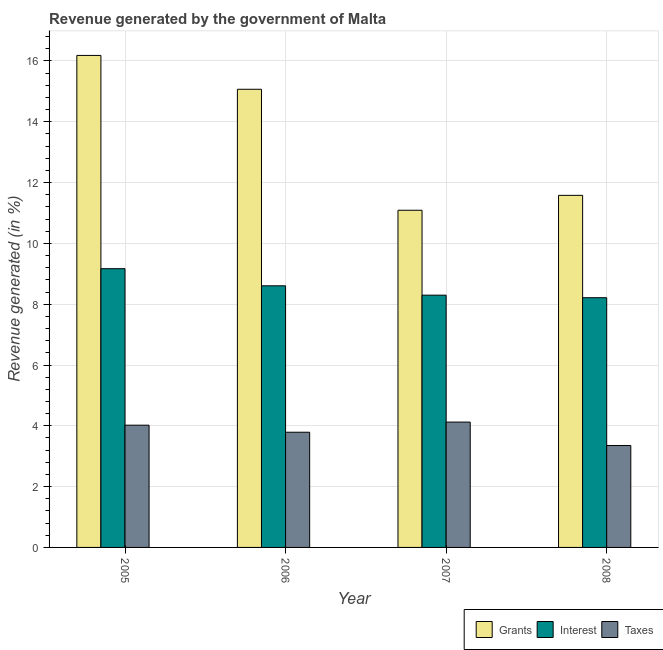Are the number of bars per tick equal to the number of legend labels?
Give a very brief answer. Yes. What is the label of the 2nd group of bars from the left?
Your response must be concise. 2006. In how many cases, is the number of bars for a given year not equal to the number of legend labels?
Offer a very short reply. 0. What is the percentage of revenue generated by grants in 2008?
Provide a succinct answer. 11.58. Across all years, what is the maximum percentage of revenue generated by taxes?
Offer a terse response. 4.12. Across all years, what is the minimum percentage of revenue generated by taxes?
Your response must be concise. 3.35. In which year was the percentage of revenue generated by grants maximum?
Offer a very short reply. 2005. What is the total percentage of revenue generated by taxes in the graph?
Make the answer very short. 15.29. What is the difference between the percentage of revenue generated by interest in 2007 and that in 2008?
Provide a short and direct response. 0.08. What is the difference between the percentage of revenue generated by grants in 2008 and the percentage of revenue generated by interest in 2005?
Your answer should be compact. -4.6. What is the average percentage of revenue generated by interest per year?
Keep it short and to the point. 8.57. In the year 2007, what is the difference between the percentage of revenue generated by interest and percentage of revenue generated by taxes?
Give a very brief answer. 0. What is the ratio of the percentage of revenue generated by taxes in 2006 to that in 2008?
Your response must be concise. 1.13. Is the difference between the percentage of revenue generated by taxes in 2006 and 2008 greater than the difference between the percentage of revenue generated by interest in 2006 and 2008?
Your answer should be very brief. No. What is the difference between the highest and the second highest percentage of revenue generated by grants?
Provide a short and direct response. 1.11. What is the difference between the highest and the lowest percentage of revenue generated by taxes?
Ensure brevity in your answer.  0.77. In how many years, is the percentage of revenue generated by interest greater than the average percentage of revenue generated by interest taken over all years?
Your answer should be very brief. 2. Is the sum of the percentage of revenue generated by taxes in 2005 and 2007 greater than the maximum percentage of revenue generated by grants across all years?
Provide a short and direct response. Yes. What does the 3rd bar from the left in 2008 represents?
Provide a short and direct response. Taxes. What does the 1st bar from the right in 2007 represents?
Give a very brief answer. Taxes. Is it the case that in every year, the sum of the percentage of revenue generated by grants and percentage of revenue generated by interest is greater than the percentage of revenue generated by taxes?
Keep it short and to the point. Yes. How many bars are there?
Ensure brevity in your answer.  12. What is the difference between two consecutive major ticks on the Y-axis?
Your response must be concise. 2. Are the values on the major ticks of Y-axis written in scientific E-notation?
Give a very brief answer. No. Does the graph contain any zero values?
Ensure brevity in your answer.  No. How many legend labels are there?
Your answer should be very brief. 3. What is the title of the graph?
Ensure brevity in your answer.  Revenue generated by the government of Malta. What is the label or title of the Y-axis?
Provide a short and direct response. Revenue generated (in %). What is the Revenue generated (in %) in Grants in 2005?
Offer a very short reply. 16.18. What is the Revenue generated (in %) of Interest in 2005?
Your answer should be very brief. 9.17. What is the Revenue generated (in %) of Taxes in 2005?
Your answer should be very brief. 4.02. What is the Revenue generated (in %) in Grants in 2006?
Provide a succinct answer. 15.07. What is the Revenue generated (in %) in Interest in 2006?
Offer a very short reply. 8.6. What is the Revenue generated (in %) in Taxes in 2006?
Make the answer very short. 3.79. What is the Revenue generated (in %) in Grants in 2007?
Provide a succinct answer. 11.09. What is the Revenue generated (in %) in Interest in 2007?
Offer a terse response. 8.3. What is the Revenue generated (in %) in Taxes in 2007?
Provide a succinct answer. 4.12. What is the Revenue generated (in %) of Grants in 2008?
Make the answer very short. 11.58. What is the Revenue generated (in %) of Interest in 2008?
Keep it short and to the point. 8.21. What is the Revenue generated (in %) in Taxes in 2008?
Offer a very short reply. 3.35. Across all years, what is the maximum Revenue generated (in %) of Grants?
Make the answer very short. 16.18. Across all years, what is the maximum Revenue generated (in %) in Interest?
Ensure brevity in your answer.  9.17. Across all years, what is the maximum Revenue generated (in %) in Taxes?
Provide a succinct answer. 4.12. Across all years, what is the minimum Revenue generated (in %) of Grants?
Provide a short and direct response. 11.09. Across all years, what is the minimum Revenue generated (in %) in Interest?
Offer a very short reply. 8.21. Across all years, what is the minimum Revenue generated (in %) of Taxes?
Make the answer very short. 3.35. What is the total Revenue generated (in %) of Grants in the graph?
Offer a very short reply. 53.92. What is the total Revenue generated (in %) of Interest in the graph?
Provide a short and direct response. 34.28. What is the total Revenue generated (in %) of Taxes in the graph?
Your answer should be compact. 15.29. What is the difference between the Revenue generated (in %) in Grants in 2005 and that in 2006?
Provide a short and direct response. 1.11. What is the difference between the Revenue generated (in %) in Interest in 2005 and that in 2006?
Your answer should be very brief. 0.56. What is the difference between the Revenue generated (in %) in Taxes in 2005 and that in 2006?
Make the answer very short. 0.23. What is the difference between the Revenue generated (in %) in Grants in 2005 and that in 2007?
Offer a terse response. 5.09. What is the difference between the Revenue generated (in %) of Interest in 2005 and that in 2007?
Offer a very short reply. 0.87. What is the difference between the Revenue generated (in %) in Taxes in 2005 and that in 2007?
Offer a terse response. -0.1. What is the difference between the Revenue generated (in %) of Grants in 2005 and that in 2008?
Your response must be concise. 4.6. What is the difference between the Revenue generated (in %) in Interest in 2005 and that in 2008?
Ensure brevity in your answer.  0.95. What is the difference between the Revenue generated (in %) of Taxes in 2005 and that in 2008?
Your response must be concise. 0.67. What is the difference between the Revenue generated (in %) in Grants in 2006 and that in 2007?
Offer a very short reply. 3.98. What is the difference between the Revenue generated (in %) in Interest in 2006 and that in 2007?
Provide a succinct answer. 0.31. What is the difference between the Revenue generated (in %) in Taxes in 2006 and that in 2007?
Your response must be concise. -0.33. What is the difference between the Revenue generated (in %) in Grants in 2006 and that in 2008?
Offer a very short reply. 3.49. What is the difference between the Revenue generated (in %) in Interest in 2006 and that in 2008?
Ensure brevity in your answer.  0.39. What is the difference between the Revenue generated (in %) in Taxes in 2006 and that in 2008?
Make the answer very short. 0.44. What is the difference between the Revenue generated (in %) of Grants in 2007 and that in 2008?
Offer a terse response. -0.49. What is the difference between the Revenue generated (in %) of Interest in 2007 and that in 2008?
Provide a succinct answer. 0.08. What is the difference between the Revenue generated (in %) of Taxes in 2007 and that in 2008?
Make the answer very short. 0.77. What is the difference between the Revenue generated (in %) in Grants in 2005 and the Revenue generated (in %) in Interest in 2006?
Give a very brief answer. 7.58. What is the difference between the Revenue generated (in %) in Grants in 2005 and the Revenue generated (in %) in Taxes in 2006?
Keep it short and to the point. 12.39. What is the difference between the Revenue generated (in %) in Interest in 2005 and the Revenue generated (in %) in Taxes in 2006?
Keep it short and to the point. 5.38. What is the difference between the Revenue generated (in %) in Grants in 2005 and the Revenue generated (in %) in Interest in 2007?
Provide a succinct answer. 7.89. What is the difference between the Revenue generated (in %) of Grants in 2005 and the Revenue generated (in %) of Taxes in 2007?
Offer a very short reply. 12.06. What is the difference between the Revenue generated (in %) of Interest in 2005 and the Revenue generated (in %) of Taxes in 2007?
Your answer should be compact. 5.05. What is the difference between the Revenue generated (in %) in Grants in 2005 and the Revenue generated (in %) in Interest in 2008?
Your answer should be very brief. 7.97. What is the difference between the Revenue generated (in %) in Grants in 2005 and the Revenue generated (in %) in Taxes in 2008?
Keep it short and to the point. 12.83. What is the difference between the Revenue generated (in %) in Interest in 2005 and the Revenue generated (in %) in Taxes in 2008?
Give a very brief answer. 5.81. What is the difference between the Revenue generated (in %) of Grants in 2006 and the Revenue generated (in %) of Interest in 2007?
Your answer should be very brief. 6.77. What is the difference between the Revenue generated (in %) of Grants in 2006 and the Revenue generated (in %) of Taxes in 2007?
Your answer should be very brief. 10.95. What is the difference between the Revenue generated (in %) in Interest in 2006 and the Revenue generated (in %) in Taxes in 2007?
Ensure brevity in your answer.  4.48. What is the difference between the Revenue generated (in %) in Grants in 2006 and the Revenue generated (in %) in Interest in 2008?
Keep it short and to the point. 6.86. What is the difference between the Revenue generated (in %) in Grants in 2006 and the Revenue generated (in %) in Taxes in 2008?
Offer a very short reply. 11.72. What is the difference between the Revenue generated (in %) of Interest in 2006 and the Revenue generated (in %) of Taxes in 2008?
Your answer should be compact. 5.25. What is the difference between the Revenue generated (in %) of Grants in 2007 and the Revenue generated (in %) of Interest in 2008?
Your response must be concise. 2.88. What is the difference between the Revenue generated (in %) of Grants in 2007 and the Revenue generated (in %) of Taxes in 2008?
Your response must be concise. 7.74. What is the difference between the Revenue generated (in %) of Interest in 2007 and the Revenue generated (in %) of Taxes in 2008?
Give a very brief answer. 4.94. What is the average Revenue generated (in %) of Grants per year?
Provide a short and direct response. 13.48. What is the average Revenue generated (in %) of Interest per year?
Give a very brief answer. 8.57. What is the average Revenue generated (in %) in Taxes per year?
Your answer should be compact. 3.82. In the year 2005, what is the difference between the Revenue generated (in %) of Grants and Revenue generated (in %) of Interest?
Offer a very short reply. 7.01. In the year 2005, what is the difference between the Revenue generated (in %) of Grants and Revenue generated (in %) of Taxes?
Keep it short and to the point. 12.16. In the year 2005, what is the difference between the Revenue generated (in %) in Interest and Revenue generated (in %) in Taxes?
Make the answer very short. 5.15. In the year 2006, what is the difference between the Revenue generated (in %) in Grants and Revenue generated (in %) in Interest?
Your response must be concise. 6.46. In the year 2006, what is the difference between the Revenue generated (in %) in Grants and Revenue generated (in %) in Taxes?
Your answer should be compact. 11.28. In the year 2006, what is the difference between the Revenue generated (in %) of Interest and Revenue generated (in %) of Taxes?
Offer a very short reply. 4.82. In the year 2007, what is the difference between the Revenue generated (in %) of Grants and Revenue generated (in %) of Interest?
Provide a succinct answer. 2.79. In the year 2007, what is the difference between the Revenue generated (in %) in Grants and Revenue generated (in %) in Taxes?
Keep it short and to the point. 6.97. In the year 2007, what is the difference between the Revenue generated (in %) of Interest and Revenue generated (in %) of Taxes?
Offer a terse response. 4.17. In the year 2008, what is the difference between the Revenue generated (in %) of Grants and Revenue generated (in %) of Interest?
Provide a short and direct response. 3.37. In the year 2008, what is the difference between the Revenue generated (in %) in Grants and Revenue generated (in %) in Taxes?
Provide a short and direct response. 8.23. In the year 2008, what is the difference between the Revenue generated (in %) in Interest and Revenue generated (in %) in Taxes?
Keep it short and to the point. 4.86. What is the ratio of the Revenue generated (in %) in Grants in 2005 to that in 2006?
Give a very brief answer. 1.07. What is the ratio of the Revenue generated (in %) in Interest in 2005 to that in 2006?
Make the answer very short. 1.07. What is the ratio of the Revenue generated (in %) in Taxes in 2005 to that in 2006?
Offer a terse response. 1.06. What is the ratio of the Revenue generated (in %) in Grants in 2005 to that in 2007?
Your answer should be compact. 1.46. What is the ratio of the Revenue generated (in %) of Interest in 2005 to that in 2007?
Offer a terse response. 1.1. What is the ratio of the Revenue generated (in %) of Taxes in 2005 to that in 2007?
Offer a terse response. 0.98. What is the ratio of the Revenue generated (in %) of Grants in 2005 to that in 2008?
Your answer should be compact. 1.4. What is the ratio of the Revenue generated (in %) in Interest in 2005 to that in 2008?
Your response must be concise. 1.12. What is the ratio of the Revenue generated (in %) of Taxes in 2005 to that in 2008?
Provide a succinct answer. 1.2. What is the ratio of the Revenue generated (in %) in Grants in 2006 to that in 2007?
Your response must be concise. 1.36. What is the ratio of the Revenue generated (in %) in Interest in 2006 to that in 2007?
Make the answer very short. 1.04. What is the ratio of the Revenue generated (in %) of Taxes in 2006 to that in 2007?
Provide a succinct answer. 0.92. What is the ratio of the Revenue generated (in %) in Grants in 2006 to that in 2008?
Your answer should be compact. 1.3. What is the ratio of the Revenue generated (in %) in Interest in 2006 to that in 2008?
Offer a very short reply. 1.05. What is the ratio of the Revenue generated (in %) in Taxes in 2006 to that in 2008?
Offer a terse response. 1.13. What is the ratio of the Revenue generated (in %) of Grants in 2007 to that in 2008?
Make the answer very short. 0.96. What is the ratio of the Revenue generated (in %) in Interest in 2007 to that in 2008?
Offer a very short reply. 1.01. What is the ratio of the Revenue generated (in %) of Taxes in 2007 to that in 2008?
Your answer should be compact. 1.23. What is the difference between the highest and the second highest Revenue generated (in %) of Grants?
Offer a very short reply. 1.11. What is the difference between the highest and the second highest Revenue generated (in %) of Interest?
Give a very brief answer. 0.56. What is the difference between the highest and the second highest Revenue generated (in %) of Taxes?
Provide a short and direct response. 0.1. What is the difference between the highest and the lowest Revenue generated (in %) in Grants?
Offer a terse response. 5.09. What is the difference between the highest and the lowest Revenue generated (in %) of Interest?
Provide a short and direct response. 0.95. What is the difference between the highest and the lowest Revenue generated (in %) in Taxes?
Your answer should be very brief. 0.77. 